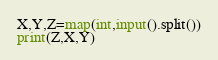Convert code to text. <code><loc_0><loc_0><loc_500><loc_500><_Python_>X,Y,Z=map(int,input().split())
print(Z,X,Y)
</code> 